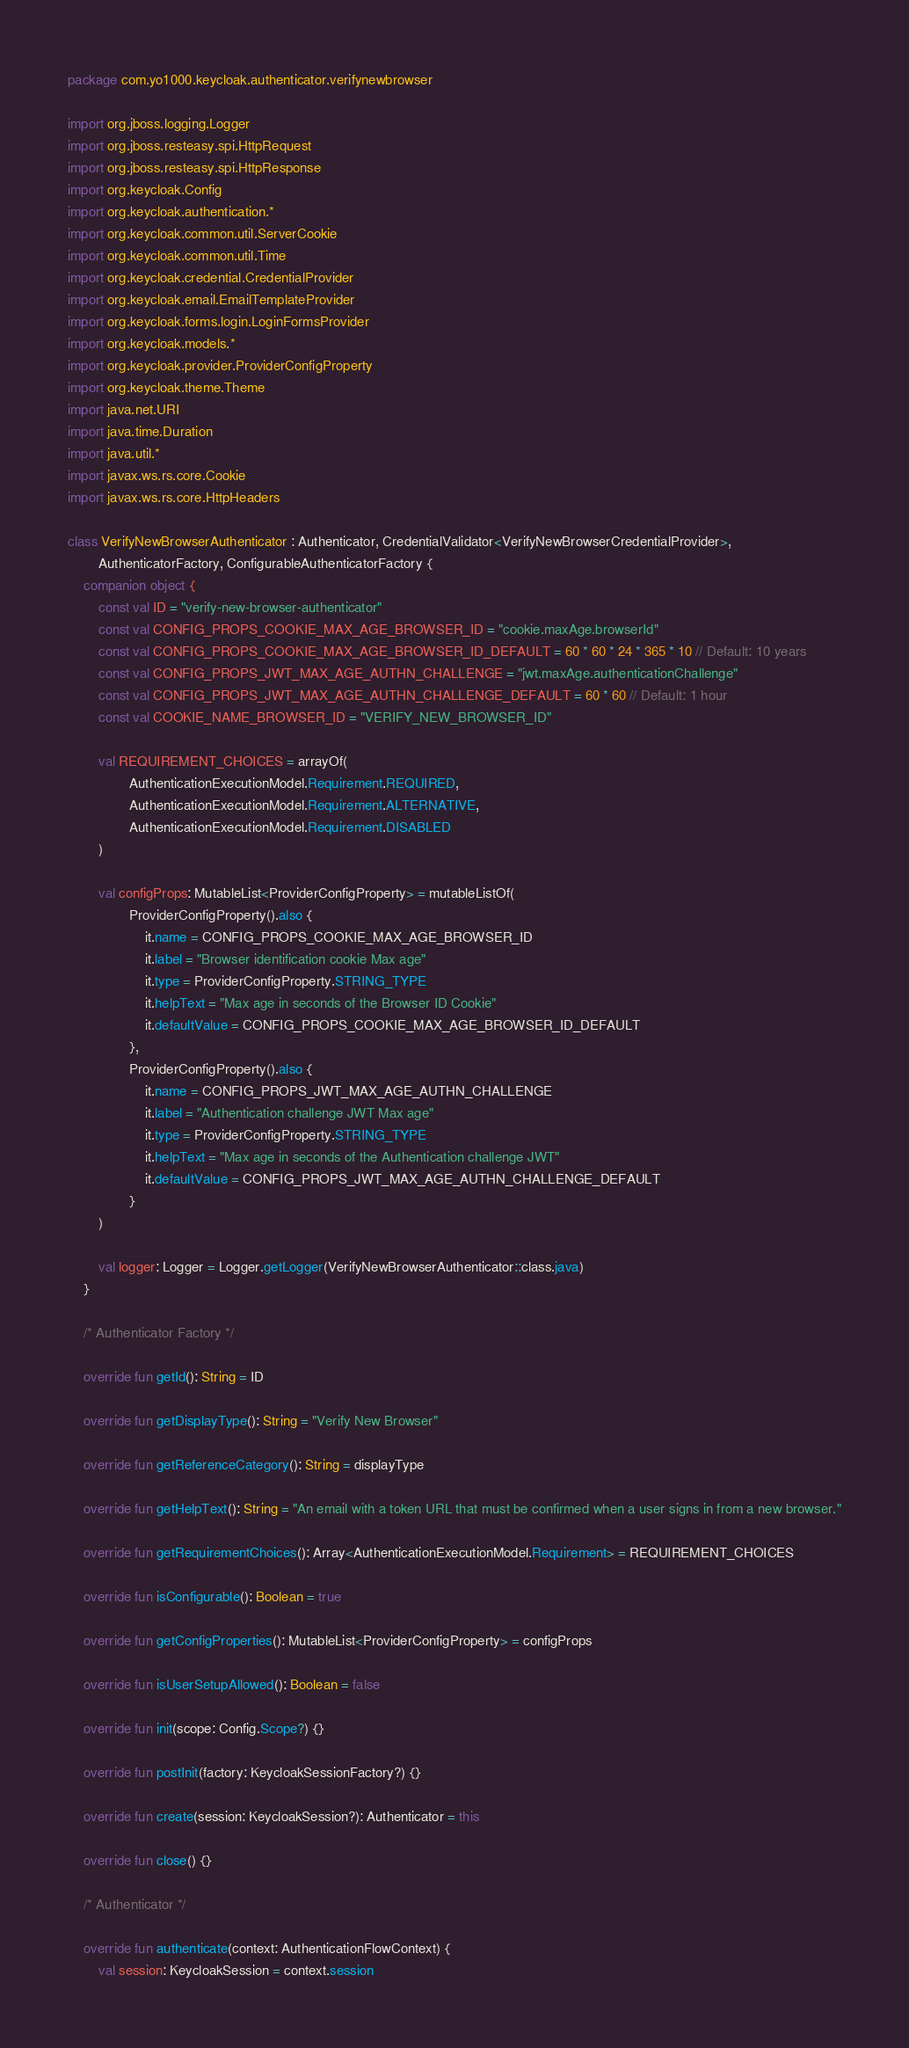Convert code to text. <code><loc_0><loc_0><loc_500><loc_500><_Kotlin_>package com.yo1000.keycloak.authenticator.verifynewbrowser

import org.jboss.logging.Logger
import org.jboss.resteasy.spi.HttpRequest
import org.jboss.resteasy.spi.HttpResponse
import org.keycloak.Config
import org.keycloak.authentication.*
import org.keycloak.common.util.ServerCookie
import org.keycloak.common.util.Time
import org.keycloak.credential.CredentialProvider
import org.keycloak.email.EmailTemplateProvider
import org.keycloak.forms.login.LoginFormsProvider
import org.keycloak.models.*
import org.keycloak.provider.ProviderConfigProperty
import org.keycloak.theme.Theme
import java.net.URI
import java.time.Duration
import java.util.*
import javax.ws.rs.core.Cookie
import javax.ws.rs.core.HttpHeaders

class VerifyNewBrowserAuthenticator : Authenticator, CredentialValidator<VerifyNewBrowserCredentialProvider>,
        AuthenticatorFactory, ConfigurableAuthenticatorFactory {
    companion object {
        const val ID = "verify-new-browser-authenticator"
        const val CONFIG_PROPS_COOKIE_MAX_AGE_BROWSER_ID = "cookie.maxAge.browserId"
        const val CONFIG_PROPS_COOKIE_MAX_AGE_BROWSER_ID_DEFAULT = 60 * 60 * 24 * 365 * 10 // Default: 10 years
        const val CONFIG_PROPS_JWT_MAX_AGE_AUTHN_CHALLENGE = "jwt.maxAge.authenticationChallenge"
        const val CONFIG_PROPS_JWT_MAX_AGE_AUTHN_CHALLENGE_DEFAULT = 60 * 60 // Default: 1 hour
        const val COOKIE_NAME_BROWSER_ID = "VERIFY_NEW_BROWSER_ID"

        val REQUIREMENT_CHOICES = arrayOf(
                AuthenticationExecutionModel.Requirement.REQUIRED,
                AuthenticationExecutionModel.Requirement.ALTERNATIVE,
                AuthenticationExecutionModel.Requirement.DISABLED
        )

        val configProps: MutableList<ProviderConfigProperty> = mutableListOf(
                ProviderConfigProperty().also {
                    it.name = CONFIG_PROPS_COOKIE_MAX_AGE_BROWSER_ID
                    it.label = "Browser identification cookie Max age"
                    it.type = ProviderConfigProperty.STRING_TYPE
                    it.helpText = "Max age in seconds of the Browser ID Cookie"
                    it.defaultValue = CONFIG_PROPS_COOKIE_MAX_AGE_BROWSER_ID_DEFAULT
                },
                ProviderConfigProperty().also {
                    it.name = CONFIG_PROPS_JWT_MAX_AGE_AUTHN_CHALLENGE
                    it.label = "Authentication challenge JWT Max age"
                    it.type = ProviderConfigProperty.STRING_TYPE
                    it.helpText = "Max age in seconds of the Authentication challenge JWT"
                    it.defaultValue = CONFIG_PROPS_JWT_MAX_AGE_AUTHN_CHALLENGE_DEFAULT
                }
        )

        val logger: Logger = Logger.getLogger(VerifyNewBrowserAuthenticator::class.java)
    }

    /* Authenticator Factory */

    override fun getId(): String = ID

    override fun getDisplayType(): String = "Verify New Browser"

    override fun getReferenceCategory(): String = displayType

    override fun getHelpText(): String = "An email with a token URL that must be confirmed when a user signs in from a new browser."

    override fun getRequirementChoices(): Array<AuthenticationExecutionModel.Requirement> = REQUIREMENT_CHOICES

    override fun isConfigurable(): Boolean = true

    override fun getConfigProperties(): MutableList<ProviderConfigProperty> = configProps

    override fun isUserSetupAllowed(): Boolean = false

    override fun init(scope: Config.Scope?) {}

    override fun postInit(factory: KeycloakSessionFactory?) {}

    override fun create(session: KeycloakSession?): Authenticator = this

    override fun close() {}

    /* Authenticator */

    override fun authenticate(context: AuthenticationFlowContext) {
        val session: KeycloakSession = context.session</code> 